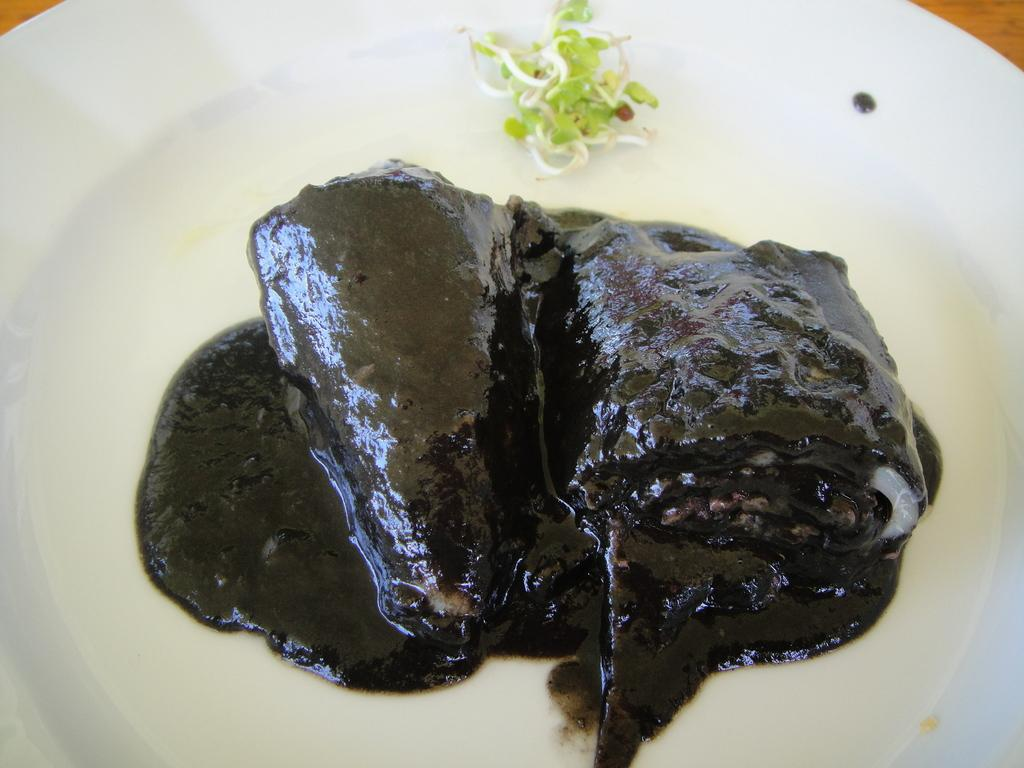What is the main subject of the image? There is a food item in the image. How is the food item presented in the image? The food item is on a white plate. What type of underwear is visible in the image? There is no underwear present in the image. What is the crack in the image referring to? There is no crack mentioned or visible in the image. 